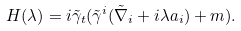Convert formula to latex. <formula><loc_0><loc_0><loc_500><loc_500>H ( \lambda ) = i \tilde { \gamma } _ { t } ( \tilde { \gamma } ^ { i } ( \tilde { \nabla } _ { i } + i \lambda a _ { i } ) + m ) .</formula> 